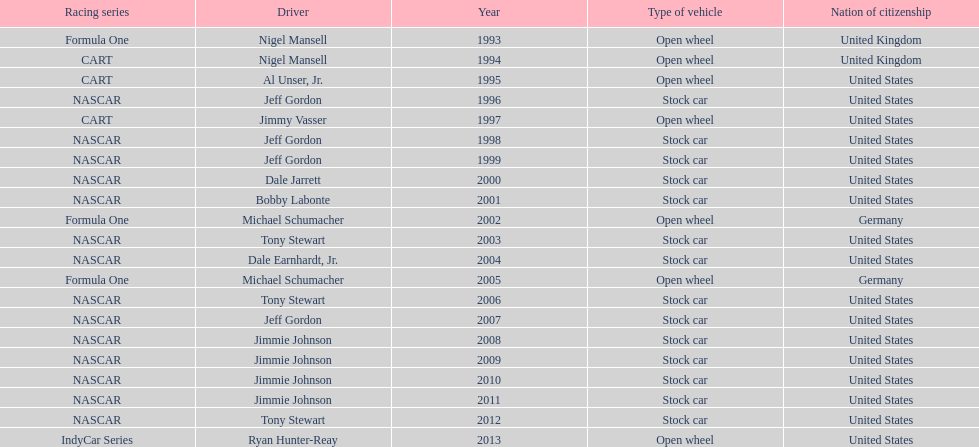Which driver won espy awards 11 years apart from each other? Jeff Gordon. 